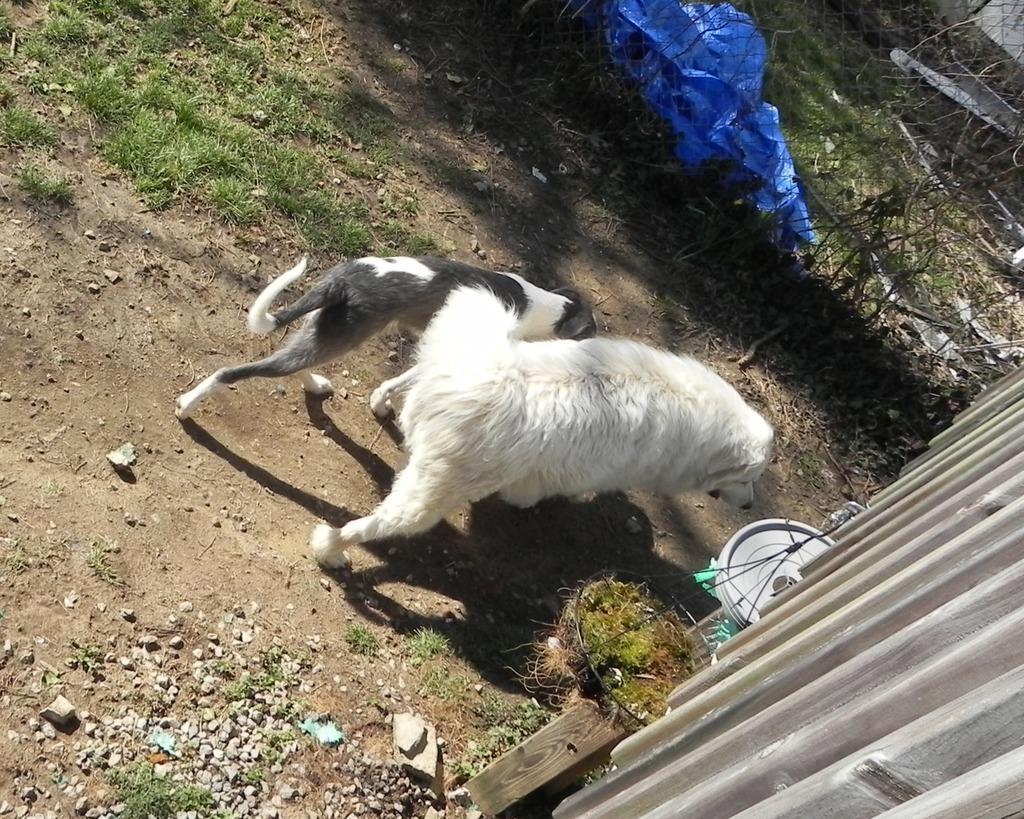Please provide a concise description of this image. In the foreground of this image, there are two dogs. On the right, there is a wooden structure, a potted plant and a white color circular object. At the top, there is a blue color plastic sheet on the grass and also we can see few dry leaves. 